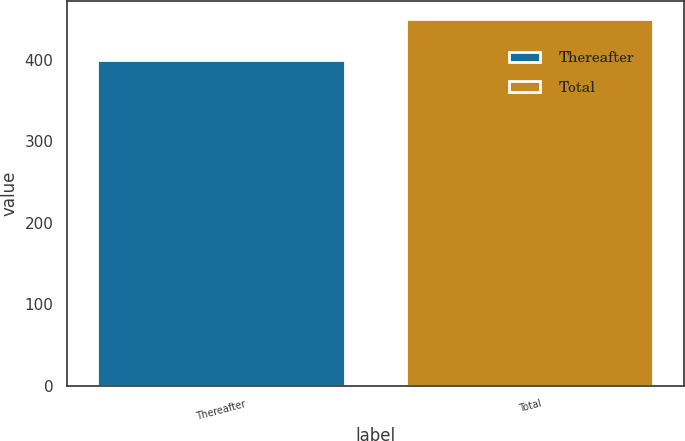Convert chart to OTSL. <chart><loc_0><loc_0><loc_500><loc_500><bar_chart><fcel>Thereafter<fcel>Total<nl><fcel>400<fcel>450<nl></chart> 